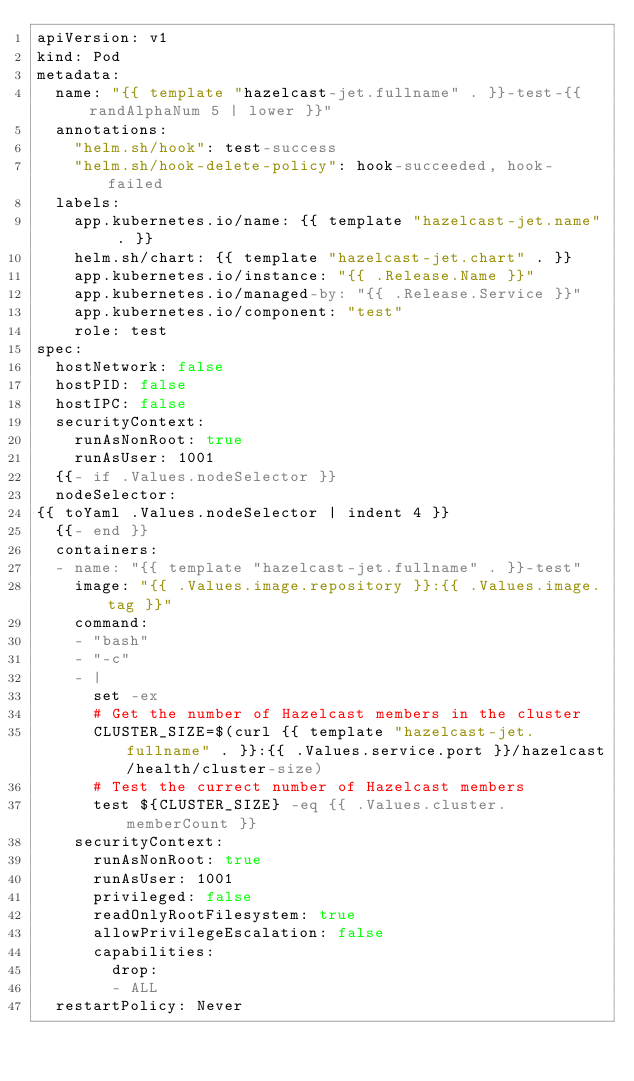Convert code to text. <code><loc_0><loc_0><loc_500><loc_500><_YAML_>apiVersion: v1
kind: Pod
metadata:
  name: "{{ template "hazelcast-jet.fullname" . }}-test-{{ randAlphaNum 5 | lower }}"
  annotations:
    "helm.sh/hook": test-success
    "helm.sh/hook-delete-policy": hook-succeeded, hook-failed
  labels:
    app.kubernetes.io/name: {{ template "hazelcast-jet.name" . }}
    helm.sh/chart: {{ template "hazelcast-jet.chart" . }}
    app.kubernetes.io/instance: "{{ .Release.Name }}"
    app.kubernetes.io/managed-by: "{{ .Release.Service }}"
    app.kubernetes.io/component: "test"
    role: test
spec:
  hostNetwork: false
  hostPID: false
  hostIPC: false
  securityContext:
    runAsNonRoot: true
    runAsUser: 1001
  {{- if .Values.nodeSelector }}
  nodeSelector:
{{ toYaml .Values.nodeSelector | indent 4 }}
  {{- end }}
  containers:
  - name: "{{ template "hazelcast-jet.fullname" . }}-test"
    image: "{{ .Values.image.repository }}:{{ .Values.image.tag }}"
    command:
    - "bash"
    - "-c"
    - |
      set -ex
      # Get the number of Hazelcast members in the cluster
      CLUSTER_SIZE=$(curl {{ template "hazelcast-jet.fullname" . }}:{{ .Values.service.port }}/hazelcast/health/cluster-size)
      # Test the currect number of Hazelcast members
      test ${CLUSTER_SIZE} -eq {{ .Values.cluster.memberCount }}
    securityContext:
      runAsNonRoot: true
      runAsUser: 1001
      privileged: false
      readOnlyRootFilesystem: true
      allowPrivilegeEscalation: false
      capabilities:
        drop:
        - ALL
  restartPolicy: Never
</code> 